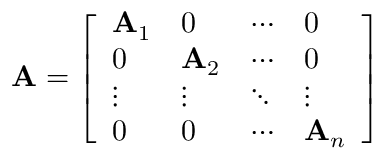<formula> <loc_0><loc_0><loc_500><loc_500>A = { \left [ \begin{array} { l l l l } { A _ { 1 } } & { 0 } & { \cdots } & { 0 } \\ { 0 } & { A _ { 2 } } & { \cdots } & { 0 } \\ { \vdots } & { \vdots } & { \ddots } & { \vdots } \\ { 0 } & { 0 } & { \cdots } & { A _ { n } } \end{array} \right ] }</formula> 